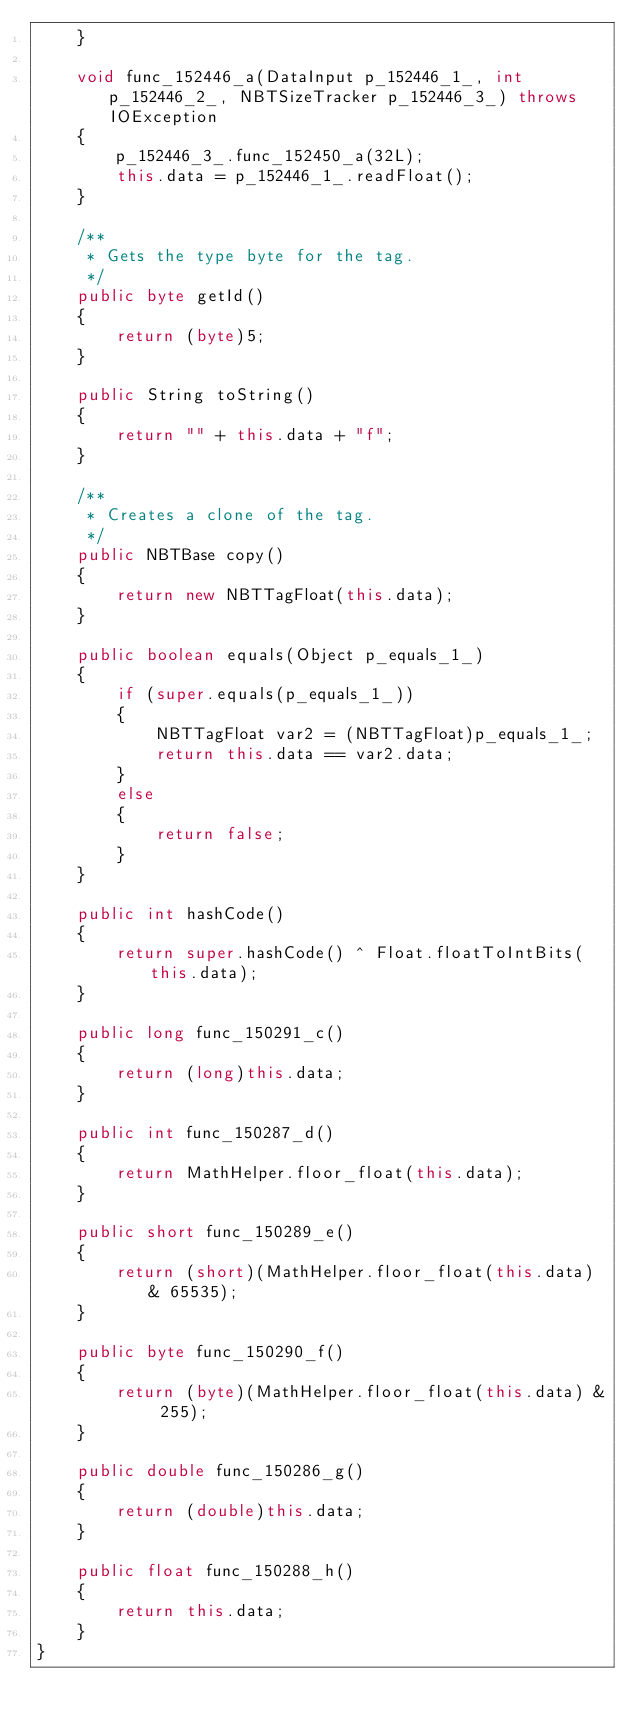<code> <loc_0><loc_0><loc_500><loc_500><_Java_>    }

    void func_152446_a(DataInput p_152446_1_, int p_152446_2_, NBTSizeTracker p_152446_3_) throws IOException
    {
        p_152446_3_.func_152450_a(32L);
        this.data = p_152446_1_.readFloat();
    }

    /**
     * Gets the type byte for the tag.
     */
    public byte getId()
    {
        return (byte)5;
    }

    public String toString()
    {
        return "" + this.data + "f";
    }

    /**
     * Creates a clone of the tag.
     */
    public NBTBase copy()
    {
        return new NBTTagFloat(this.data);
    }

    public boolean equals(Object p_equals_1_)
    {
        if (super.equals(p_equals_1_))
        {
            NBTTagFloat var2 = (NBTTagFloat)p_equals_1_;
            return this.data == var2.data;
        }
        else
        {
            return false;
        }
    }

    public int hashCode()
    {
        return super.hashCode() ^ Float.floatToIntBits(this.data);
    }

    public long func_150291_c()
    {
        return (long)this.data;
    }

    public int func_150287_d()
    {
        return MathHelper.floor_float(this.data);
    }

    public short func_150289_e()
    {
        return (short)(MathHelper.floor_float(this.data) & 65535);
    }

    public byte func_150290_f()
    {
        return (byte)(MathHelper.floor_float(this.data) & 255);
    }

    public double func_150286_g()
    {
        return (double)this.data;
    }

    public float func_150288_h()
    {
        return this.data;
    }
}
</code> 